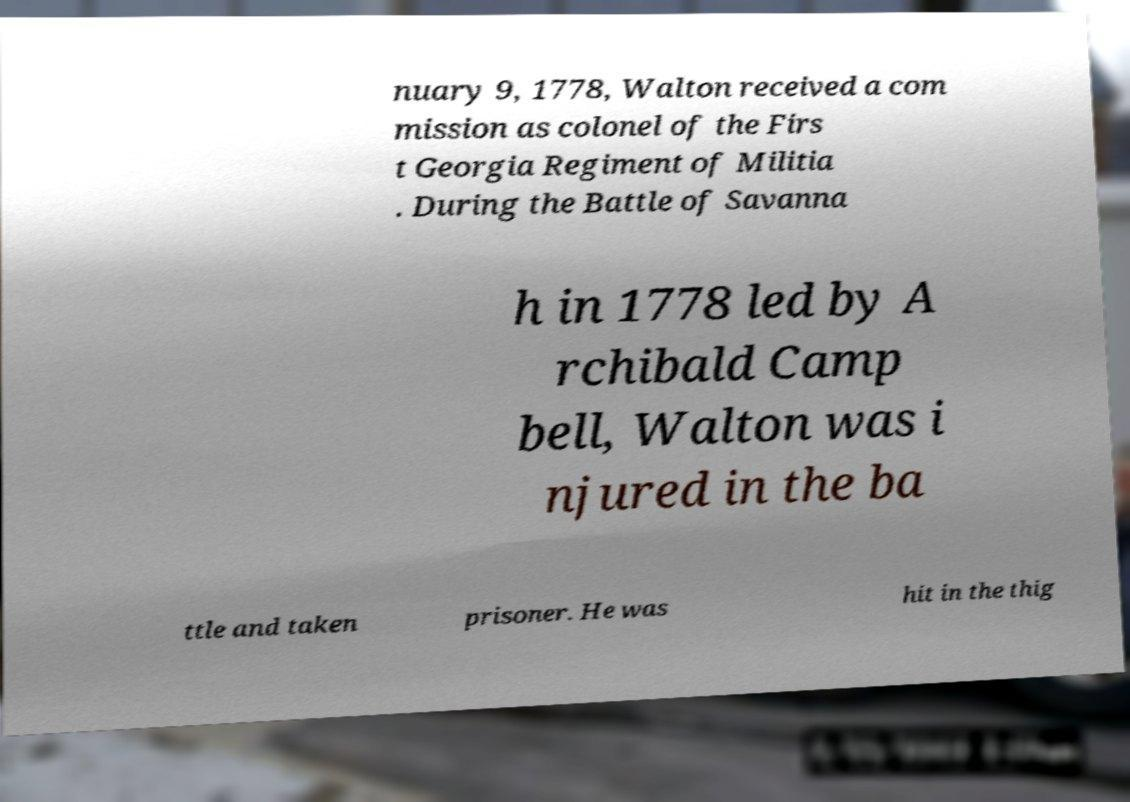Can you accurately transcribe the text from the provided image for me? nuary 9, 1778, Walton received a com mission as colonel of the Firs t Georgia Regiment of Militia . During the Battle of Savanna h in 1778 led by A rchibald Camp bell, Walton was i njured in the ba ttle and taken prisoner. He was hit in the thig 